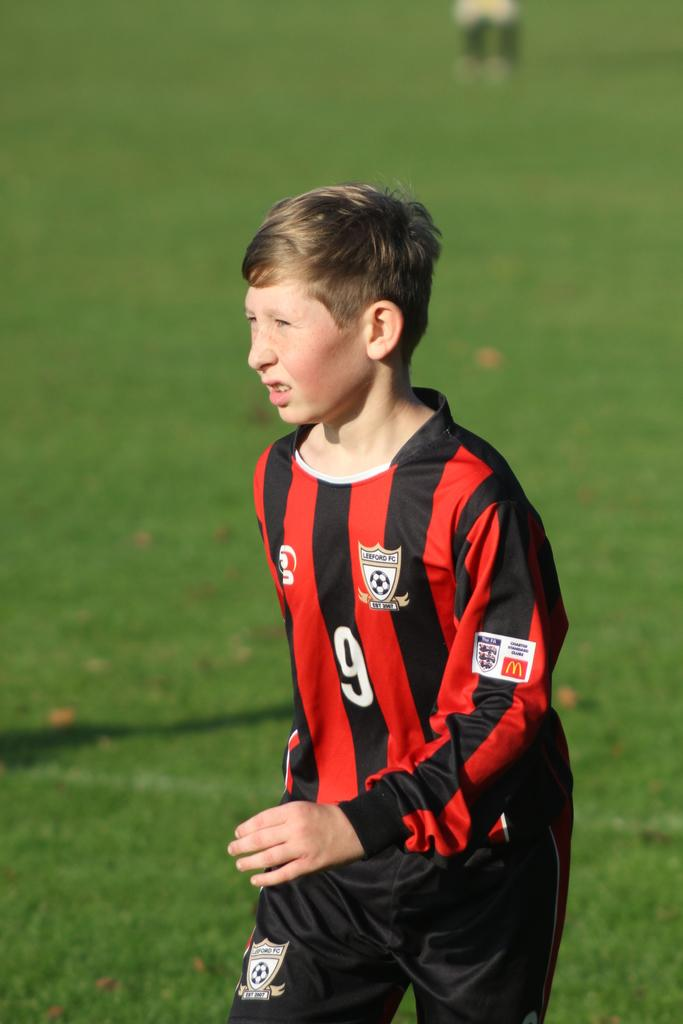Who is the main subject in the image? There is a person in the center of the image. What is the person wearing? The person is wearing a sports dress. What type of surface can be seen in the background of the image? There is ground visible in the background of the image. What type of paste is the person holding in the image? There is no paste present in the image; the person is wearing a sports dress. 